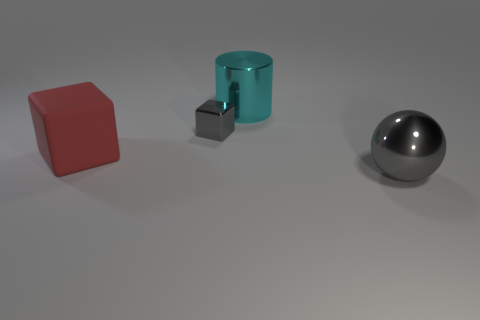Add 2 big cyan things. How many objects exist? 6 Subtract all cylinders. How many objects are left? 3 Add 1 small brown cylinders. How many small brown cylinders exist? 1 Subtract 0 purple balls. How many objects are left? 4 Subtract all cyan cylinders. Subtract all big metal balls. How many objects are left? 2 Add 2 shiny balls. How many shiny balls are left? 3 